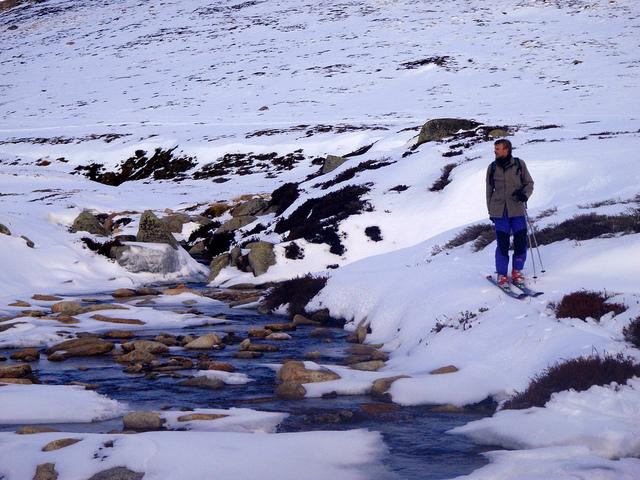What color is his jacket?
Give a very brief answer. Gray. What color coat is he wearing?
Concise answer only. Brown. What season is this picture taken in?
Keep it brief. Winter. What is the person doing?
Concise answer only. Skiing. Is the person standing still?
Answer briefly. Yes. 